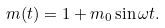Convert formula to latex. <formula><loc_0><loc_0><loc_500><loc_500>m ( t ) = 1 + m _ { 0 } \sin { \omega } t .</formula> 